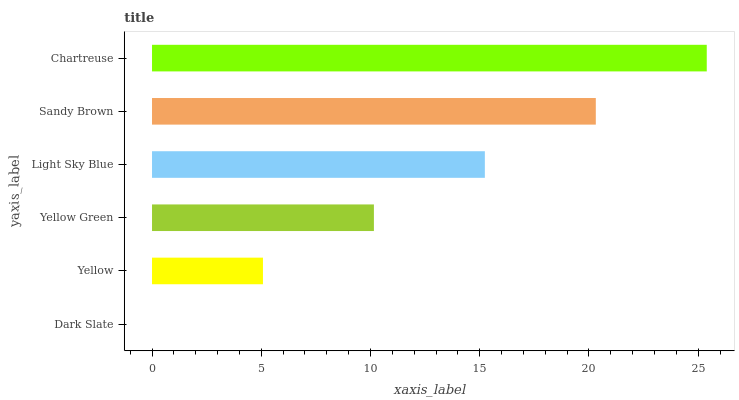Is Dark Slate the minimum?
Answer yes or no. Yes. Is Chartreuse the maximum?
Answer yes or no. Yes. Is Yellow the minimum?
Answer yes or no. No. Is Yellow the maximum?
Answer yes or no. No. Is Yellow greater than Dark Slate?
Answer yes or no. Yes. Is Dark Slate less than Yellow?
Answer yes or no. Yes. Is Dark Slate greater than Yellow?
Answer yes or no. No. Is Yellow less than Dark Slate?
Answer yes or no. No. Is Light Sky Blue the high median?
Answer yes or no. Yes. Is Yellow Green the low median?
Answer yes or no. Yes. Is Sandy Brown the high median?
Answer yes or no. No. Is Chartreuse the low median?
Answer yes or no. No. 